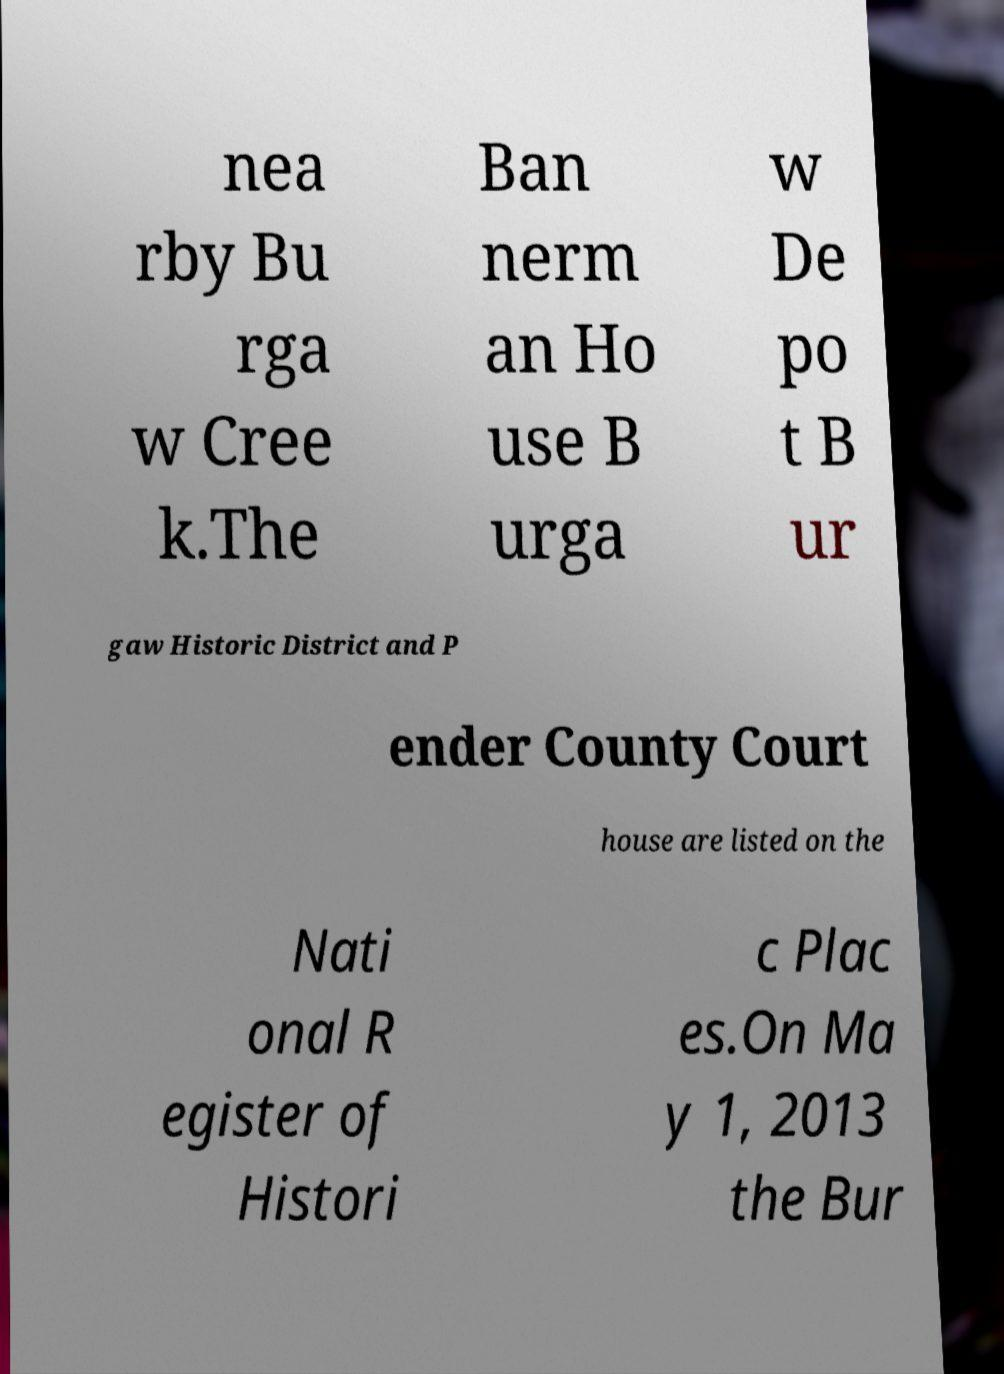Can you accurately transcribe the text from the provided image for me? nea rby Bu rga w Cree k.The Ban nerm an Ho use B urga w De po t B ur gaw Historic District and P ender County Court house are listed on the Nati onal R egister of Histori c Plac es.On Ma y 1, 2013 the Bur 